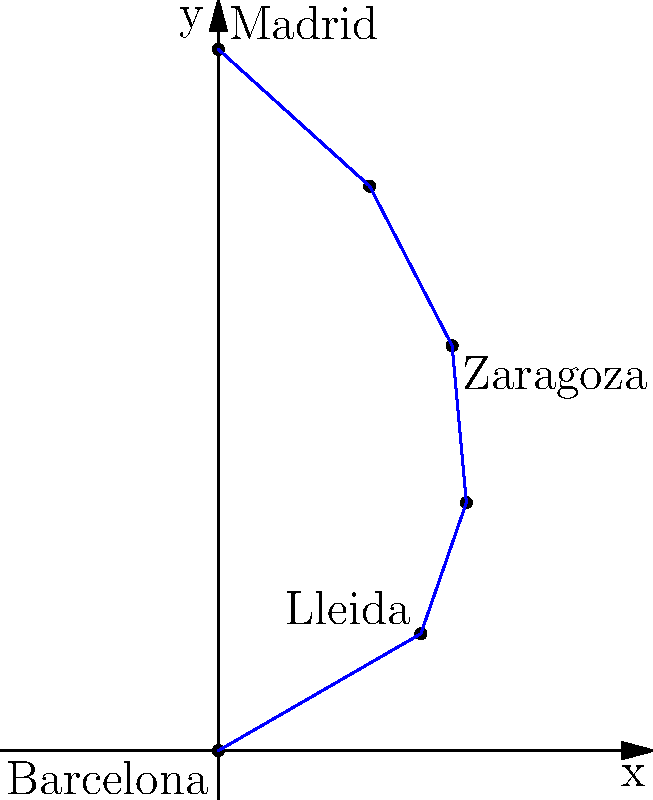Consider the train journey from Barcelona to Madrid plotted in polar coordinates, where Barcelona is at the origin and Madrid is at $(r, \theta) = (300, \frac{\pi}{2})$. If Lleida is located at $(100, \frac{\pi}{6})$ and Zaragoza at $(200, \frac{\pi}{3})$, what are the polar coordinates of the point exactly halfway between Lleida and Zaragoza? To find the polar coordinates of the point halfway between Lleida and Zaragoza, we'll follow these steps:

1) First, let's identify the given coordinates:
   Lleida: $(r_1, \theta_1) = (100, \frac{\pi}{6})$
   Zaragoza: $(r_2, \theta_2) = (200, \frac{\pi}{3})$

2) To find the midpoint, we need to average both the $r$ and $\theta$ values:

   $r_{mid} = \frac{r_1 + r_2}{2} = \frac{100 + 200}{2} = 150$

   $\theta_{mid} = \frac{\theta_1 + \theta_2}{2} = \frac{\frac{\pi}{6} + \frac{\pi}{3}}{2} = \frac{\frac{\pi}{6} + \frac{2\pi}{6}}{2} = \frac{3\pi}{12} = \frac{\pi}{4}$

3) Therefore, the polar coordinates of the midpoint are $(150, \frac{\pi}{4})$.

This point represents the location exactly halfway between Lleida and Zaragoza on the train route from Barcelona to Madrid.
Answer: $(150, \frac{\pi}{4})$ 